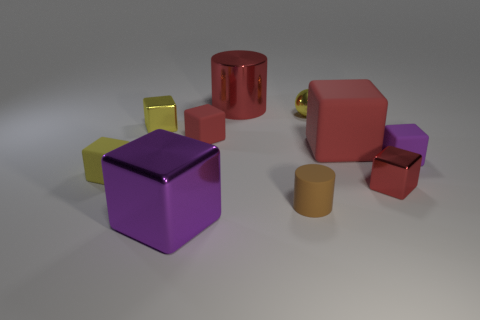What number of things are big blocks to the left of the tiny yellow metal sphere or tiny gray matte cylinders?
Your response must be concise. 1. What number of large purple balls are there?
Offer a very short reply. 0. The tiny yellow object that is the same material as the large red block is what shape?
Make the answer very short. Cube. What size is the cylinder that is in front of the matte thing on the left side of the purple metallic object?
Give a very brief answer. Small. How many objects are either small shiny objects on the right side of the big red cylinder or rubber objects behind the small yellow rubber thing?
Your response must be concise. 5. Is the number of small purple rubber objects less than the number of brown matte spheres?
Make the answer very short. No. What number of objects are red metallic things or big red rubber objects?
Keep it short and to the point. 3. Is the shape of the big red metallic thing the same as the large rubber object?
Give a very brief answer. No. There is a purple thing that is to the right of the large red matte thing; is its size the same as the red matte cube that is right of the red metallic cylinder?
Give a very brief answer. No. There is a small block that is both to the right of the big purple cube and behind the large red rubber thing; what material is it?
Offer a very short reply. Rubber. 